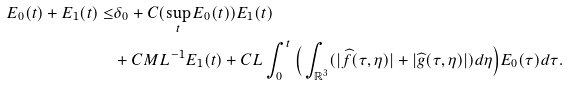Convert formula to latex. <formula><loc_0><loc_0><loc_500><loc_500>E _ { 0 } ( t ) + E _ { 1 } ( t ) \leq & \delta _ { 0 } + C ( \sup _ { t } E _ { 0 } ( t ) ) E _ { 1 } ( t ) \\ & + C M L ^ { - 1 } E _ { 1 } ( t ) + C L \int _ { 0 } ^ { t } \Big { ( } \int _ { \mathbb { R } ^ { 3 } } ( | \widehat { f } ( \tau , \eta ) | + | \widehat { g } ( \tau , \eta ) | ) d \eta \Big { ) } E _ { 0 } ( \tau ) d \tau .</formula> 